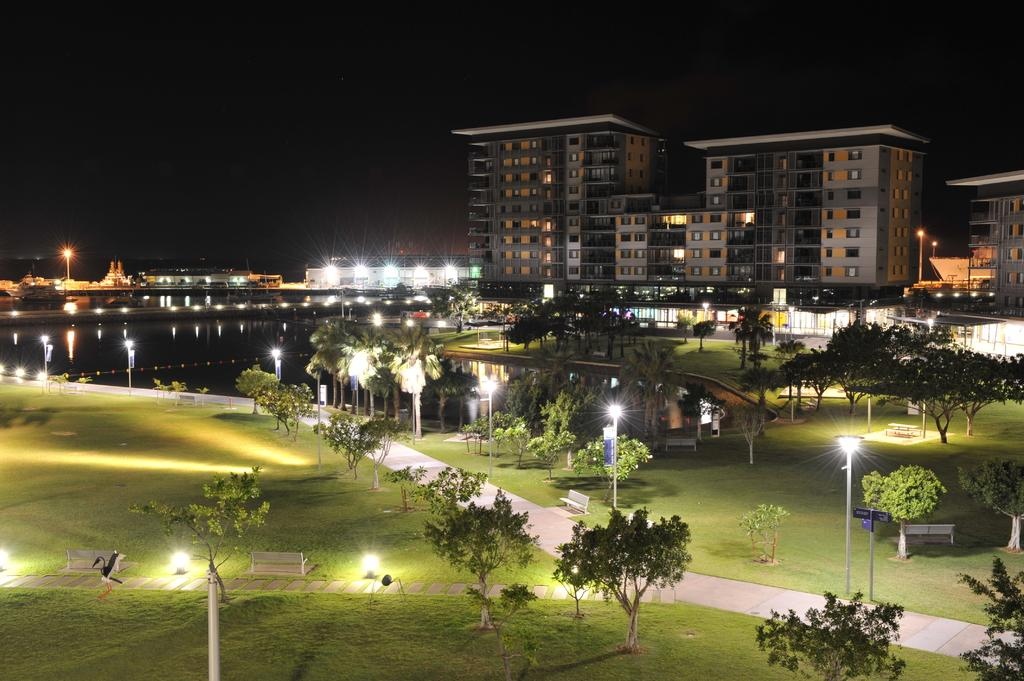What type of vegetation can be seen in the image? There are trees in the image. What type of artificial lighting is present in the image? There are street lights in the image. What type of seating is available in the image? There are benches in the image. What type of surface is visible in the image? There is a path in the image. What type of informational signs are present in the image? There are sign boards in the image. What type of natural water feature is present in the image? There is a river in the image. What type of man-made structures are present in the image? There are buildings in the image. What is the color of the background in the image? The background of the image is dark. What time of day is it in the image, and is the minister present? The time of day cannot be determined from the image, and there is no mention of a minister in the provided facts. What type of material is the wax used for in the image? There is no wax present in the image. 